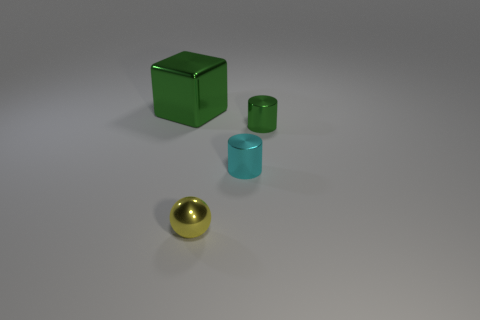Add 2 gray metal spheres. How many objects exist? 6 Subtract all cubes. How many objects are left? 3 Subtract 0 brown cylinders. How many objects are left? 4 Subtract all big metallic objects. Subtract all green cylinders. How many objects are left? 2 Add 1 large metallic cubes. How many large metallic cubes are left? 2 Add 1 purple rubber objects. How many purple rubber objects exist? 1 